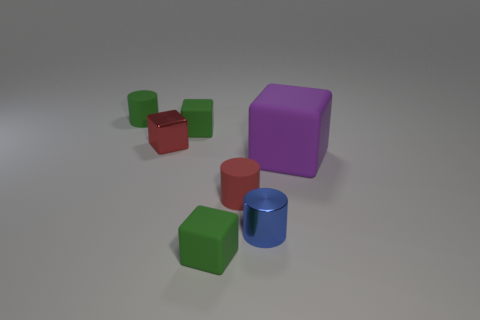Add 1 big blue cylinders. How many objects exist? 8 Subtract all cubes. How many objects are left? 3 Subtract 3 cylinders. How many cylinders are left? 0 Subtract all blue cylinders. Subtract all red spheres. How many cylinders are left? 2 Subtract all brown cubes. How many purple cylinders are left? 0 Subtract all green matte cubes. Subtract all tiny green rubber objects. How many objects are left? 2 Add 4 blue cylinders. How many blue cylinders are left? 5 Add 4 small red cubes. How many small red cubes exist? 5 Subtract all red blocks. How many blocks are left? 3 Subtract all tiny green cylinders. How many cylinders are left? 2 